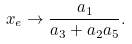Convert formula to latex. <formula><loc_0><loc_0><loc_500><loc_500>x _ { e } \rightarrow \frac { a _ { 1 } } { a _ { 3 } + a _ { 2 } a _ { 5 } } .</formula> 